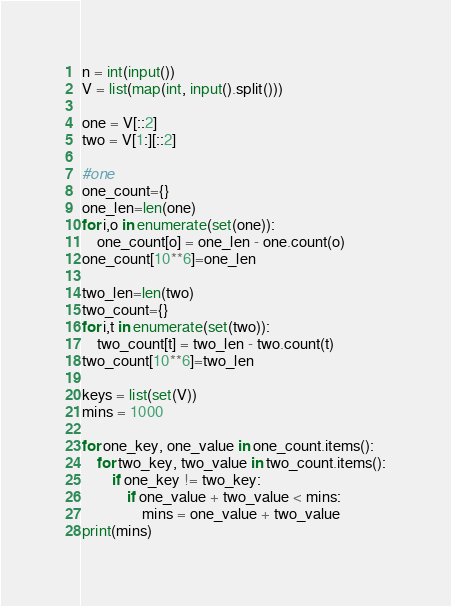<code> <loc_0><loc_0><loc_500><loc_500><_Python_>n = int(input())
V = list(map(int, input().split()))

one = V[::2]
two = V[1:][::2]

#one
one_count={}
one_len=len(one)
for i,o in enumerate(set(one)):
    one_count[o] = one_len - one.count(o)
one_count[10**6]=one_len
    
two_len=len(two)
two_count={}
for i,t in enumerate(set(two)):
    two_count[t] = two_len - two.count(t)
two_count[10**6]=two_len

keys = list(set(V))
mins = 1000

for one_key, one_value in one_count.items():
    for two_key, two_value in two_count.items():
        if one_key != two_key:
            if one_value + two_value < mins:
                mins = one_value + two_value
print(mins)</code> 